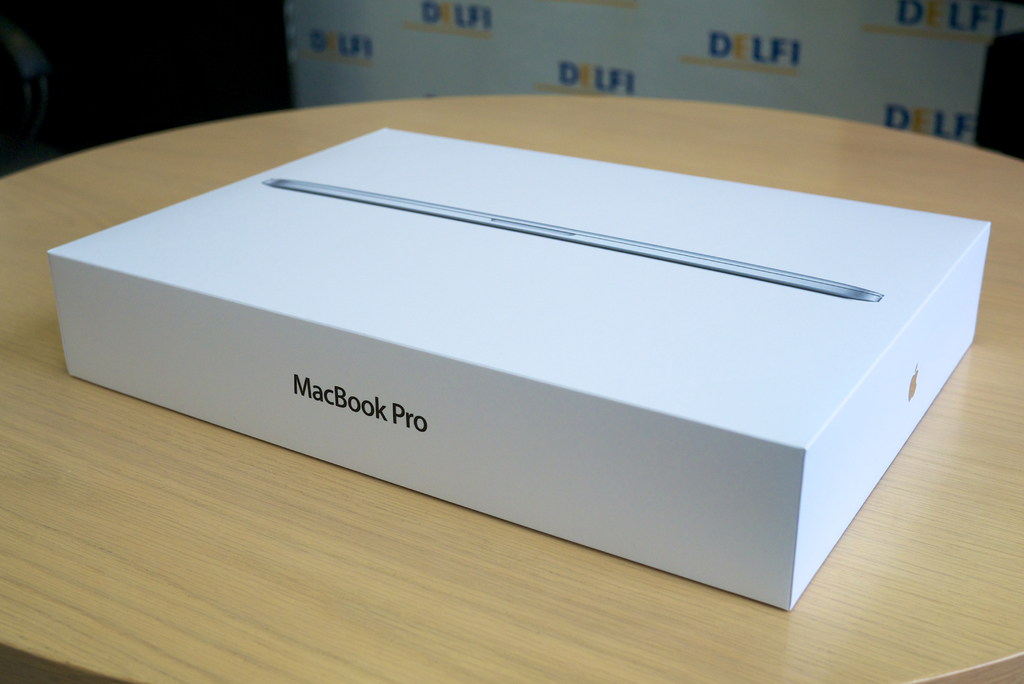What can be inferred about the target market from this image? The placement of a high-end technology product like the MacBook Pro in a deli, which might symbolize accessibility and commonality, suggests a marketing appeal to younger, urban professionals who frequent such places. This setup may be directed towards consumers who appreciate the integration of technology into various aspects of a cosmopolitan lifestyle, including dining and social settings. 